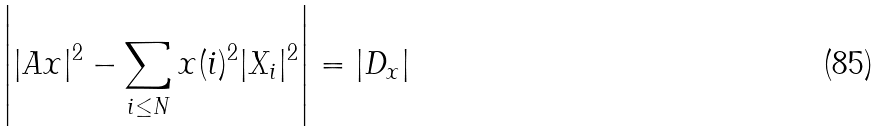Convert formula to latex. <formula><loc_0><loc_0><loc_500><loc_500>\left | | A x | ^ { 2 } - \sum _ { i \leq N } x ( i ) ^ { 2 } | X _ { i } | ^ { 2 } \right | = \left | D _ { x } \right |</formula> 